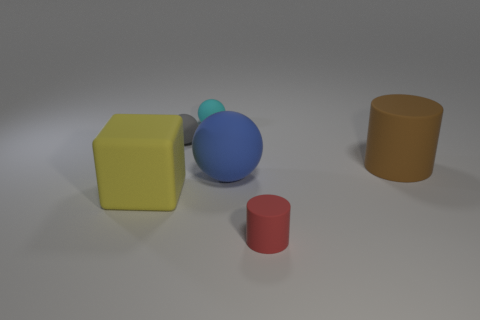What number of matte things are either big blue things or cylinders?
Your response must be concise. 3. Are there any cyan matte spheres of the same size as the blue matte ball?
Give a very brief answer. No. Is the number of large matte blocks behind the tiny cyan matte object greater than the number of blue rubber balls?
Your answer should be very brief. No. What number of big things are yellow rubber things or rubber spheres?
Provide a short and direct response. 2. How many other objects are the same shape as the red matte thing?
Provide a short and direct response. 1. The tiny sphere that is on the right side of the small thing left of the tiny cyan ball is made of what material?
Make the answer very short. Rubber. There is a matte cylinder behind the large blue matte sphere; what size is it?
Ensure brevity in your answer.  Large. What number of gray objects are either rubber balls or large balls?
Offer a very short reply. 1. Are there any other things that have the same material as the cyan thing?
Offer a terse response. Yes. What is the material of the small gray object that is the same shape as the tiny cyan thing?
Give a very brief answer. Rubber. 